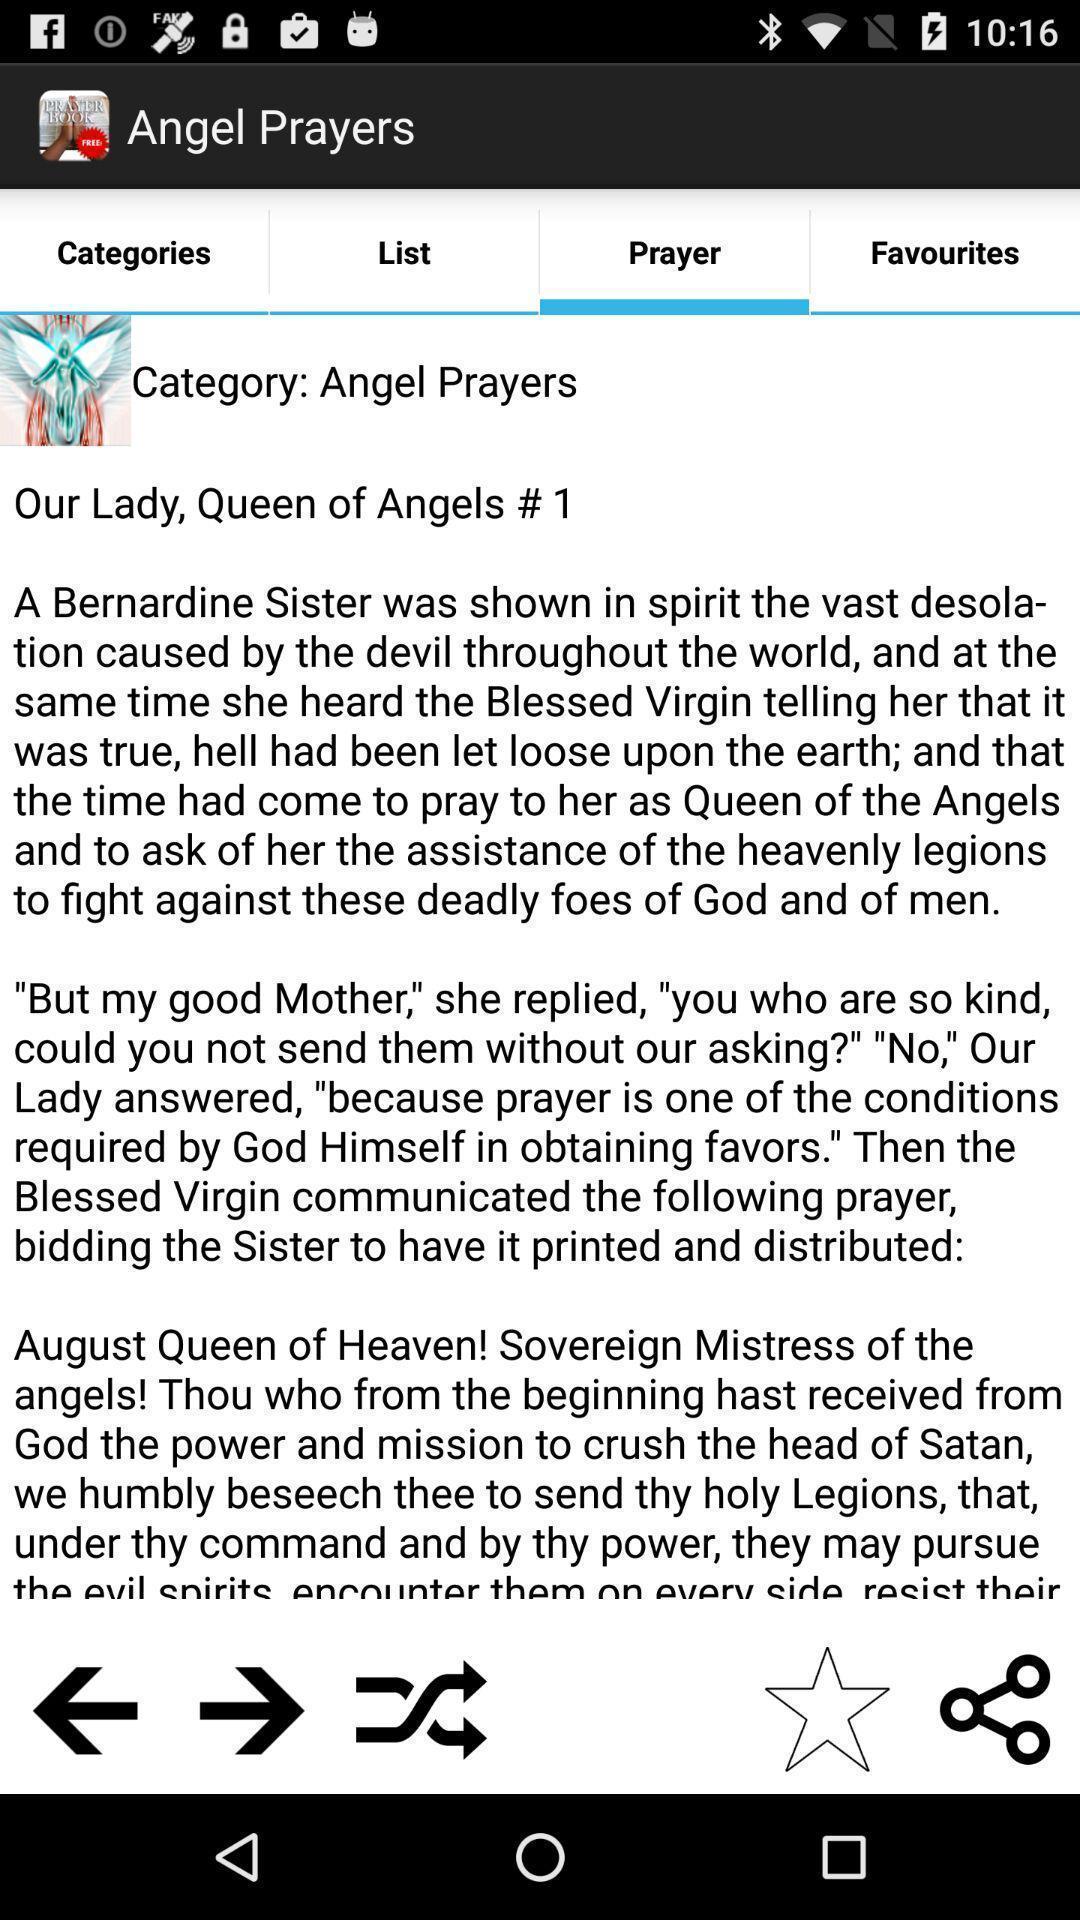Provide a description of this screenshot. Page showing the information of angel prayers. 